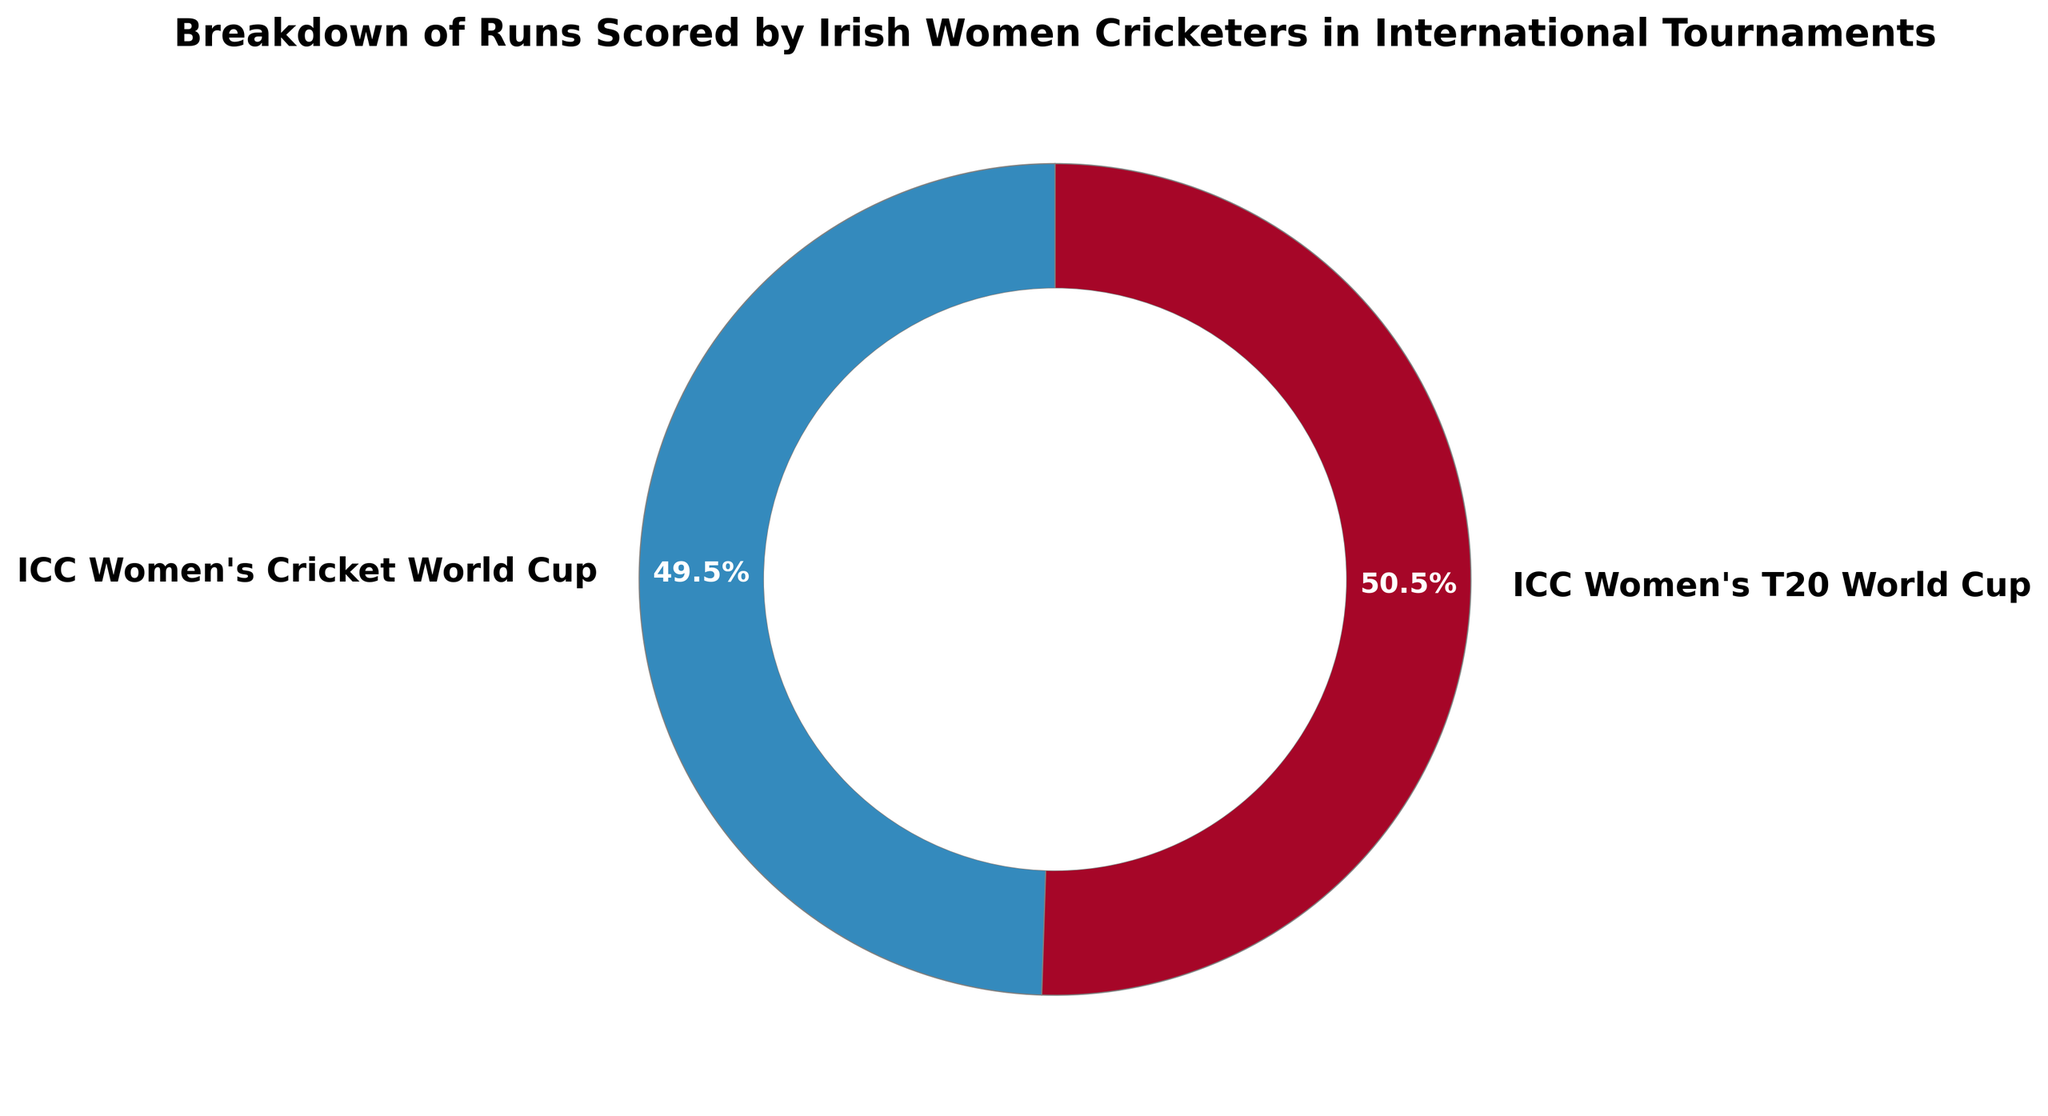What percentage of the total runs were scored in the ICC Women's Cricket World Cup? To determine this, observe the ring chart and find the percentage label associated with the ICC Women's Cricket World Cup section.
Answer: 42% What tournament had the highest percentage of total runs scored? Look for the largest segment in the ring chart and check its label for tournament name and associated percentage.
Answer: ICC Women's T20 World Cup Compare the total runs scored in the ICC Women's T20 World Cup and the ICC Women's Cricket World Cup. Which is greater? Both segments need to be compared visually by their size and by the percentage values shown within them. The one with a higher percentage is greater.
Answer: ICC Women's T20 World Cup By how much do the runs scored in the ICC Women's T20 World Cup exceed those in the ICC Women's Cricket World Cup? First, check the percentage values for both tournaments on the ring chart. Calculate the difference between the two values (58% - 42%).
Answer: 16% What is the approximate ratio of runs scored in the ICC Women's T20 World Cup to the ICC Women's Cricket World Cup? Compare the percentage of runs shown for both tournaments on the ring chart. The approximate ratio can be derived by dividing the larger percentage by the smaller one.
Answer: 58:42 or roughly 1.4:1 Is the total number of runs scored in the ICC Women's T20 World Cup more than 1.5 times that in the ICC Women's Cricket World Cup? Observe the percentage values shown in the ring chart and calculate if 58% is more than 1.5 times 42% by comparing 58% with 63% (1.5 * 42%).
Answer: No What is the difference in contributions between the two tournaments for the total runs scored by Irish women cricketers? Observe the percentage shares of total runs scored in each tournament from the ring chart. Subtract the smaller percentage from the larger one (58% - 42%).
Answer: 16% How many distinct tournaments are represented in the ring chart? Observe and count the number of unique labels outside the segments of the ring chart.
Answer: 2 